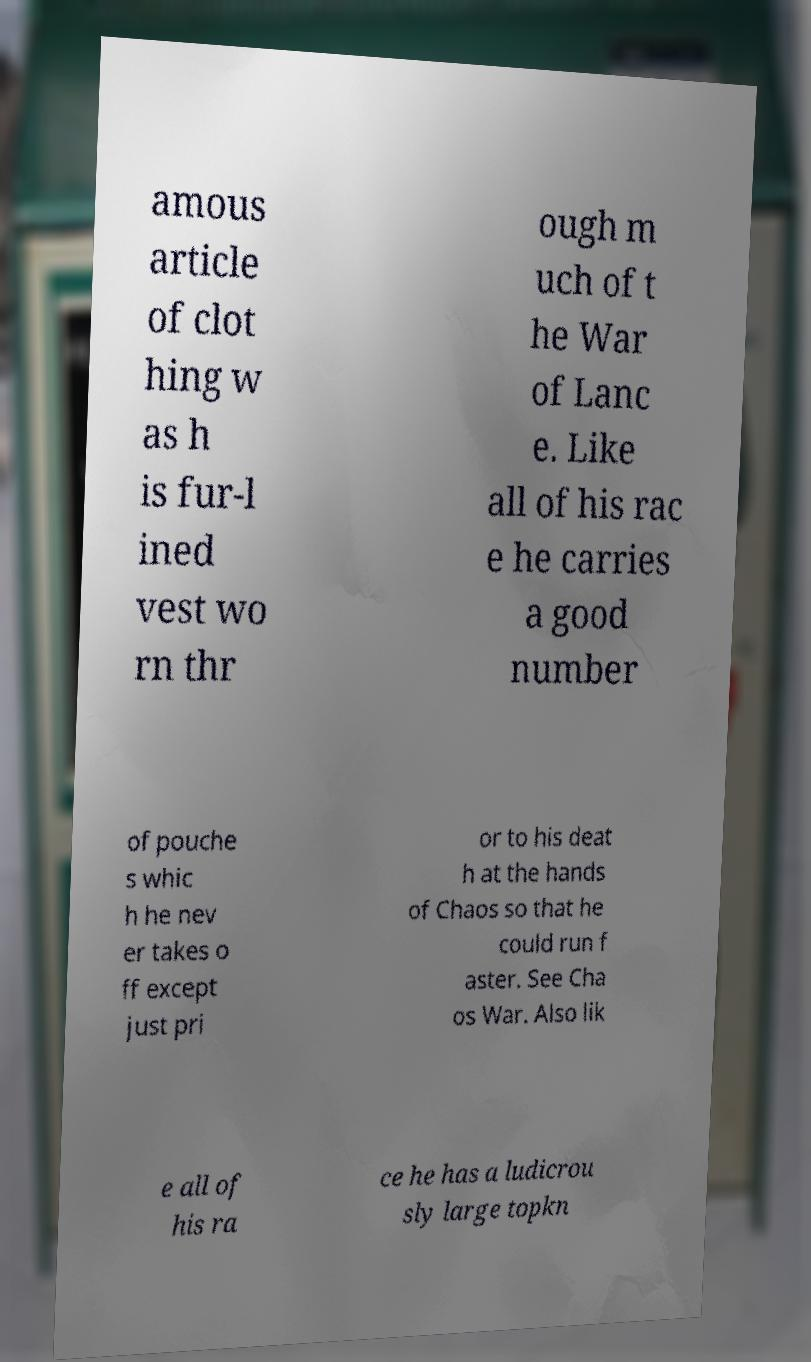Please read and relay the text visible in this image. What does it say? amous article of clot hing w as h is fur-l ined vest wo rn thr ough m uch of t he War of Lanc e. Like all of his rac e he carries a good number of pouche s whic h he nev er takes o ff except just pri or to his deat h at the hands of Chaos so that he could run f aster. See Cha os War. Also lik e all of his ra ce he has a ludicrou sly large topkn 